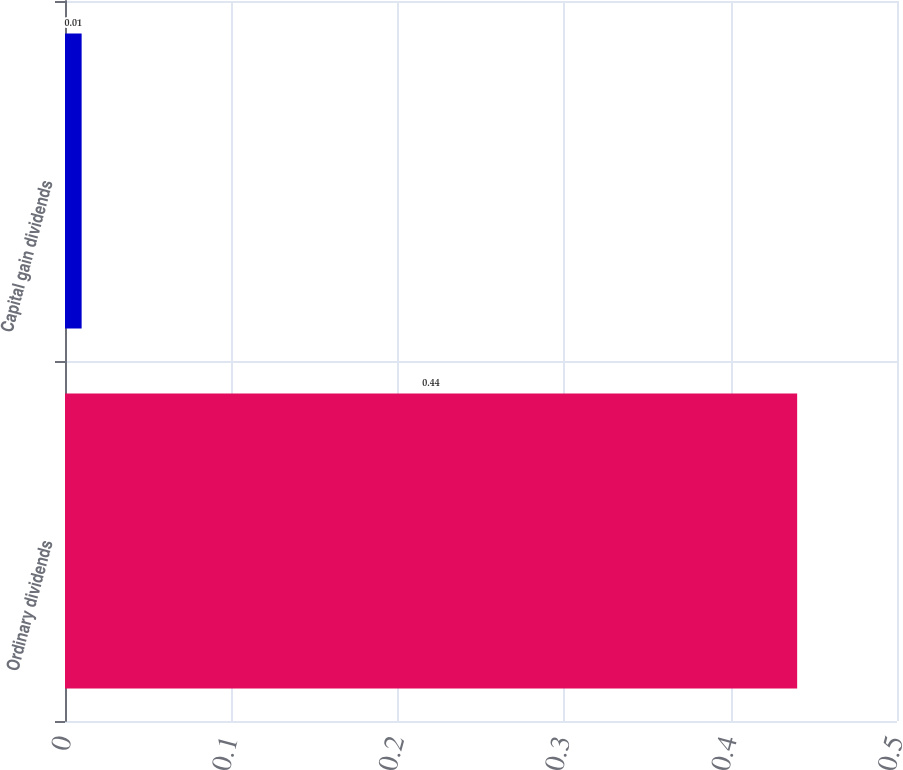Convert chart. <chart><loc_0><loc_0><loc_500><loc_500><bar_chart><fcel>Ordinary dividends<fcel>Capital gain dividends<nl><fcel>0.44<fcel>0.01<nl></chart> 